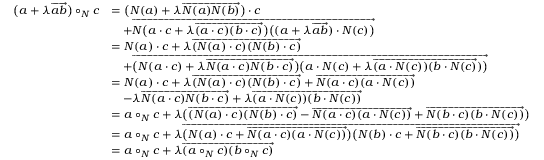<formula> <loc_0><loc_0><loc_500><loc_500>\begin{array} { r l } { \left ( a + \lambda \overrightarrow { a b } \right ) \circ _ { N } c } & { = \left ( N ( a ) + \lambda \overrightarrow { N ( a ) N ( b ) } \right ) \cdot c } \\ & { \quad + \overrightarrow { N \left ( a \cdot c + \lambda \overrightarrow { ( a \cdot c ) ( b \cdot c ) } \right ) \left ( ( a + \lambda \overrightarrow { a b } ) \cdot N ( c ) \right ) } } \\ & { = N ( a ) \cdot c + \lambda \overrightarrow { ( N ( a ) \cdot c ) ( N ( b ) \cdot c ) } } \\ & { \quad + \overrightarrow { \left ( N ( a \cdot c ) + \lambda \overrightarrow { N ( a \cdot c ) N ( b \cdot c ) } \right ) \left ( a \cdot N ( c ) + \lambda \overrightarrow { ( a \cdot N ( c ) ) ( b \cdot N ( c ) } ) \right ) } } \\ & { = N ( a ) \cdot c + \lambda \overrightarrow { ( N ( a ) \cdot c ) ( N ( b ) \cdot c ) } + \overrightarrow { N ( a \cdot c ) ( a \cdot N ( c ) ) } } \\ & { \quad - \lambda \overrightarrow { N ( a \cdot c ) N ( b \cdot c ) } + \lambda \overrightarrow { ( a \cdot N ( c ) ) ( b \cdot N ( c ) ) } } \\ & { = a \circ _ { N } c + \lambda \left ( \overrightarrow { ( N ( a ) \cdot c ) ( N ( b ) \cdot c ) } - \overrightarrow { N ( a \cdot c ) ( a \cdot N ( c ) ) } + \overrightarrow { N ( b \cdot c ) ( b \cdot N ( c ) ) } \right ) } \\ & { = a \circ _ { N } c + \lambda \overrightarrow { \left ( N ( a ) \cdot c + \overrightarrow { N ( a \cdot c ) ( a \cdot N ( c ) ) } \right ) \left ( N ( b ) \cdot c + \overrightarrow { N ( b \cdot c ) ( b \cdot N ( c ) ) } \right ) } } \\ & { = a \circ _ { N } c + \lambda \overrightarrow { ( a \circ _ { N } c ) ( b \circ _ { N } c ) } } \end{array}</formula> 